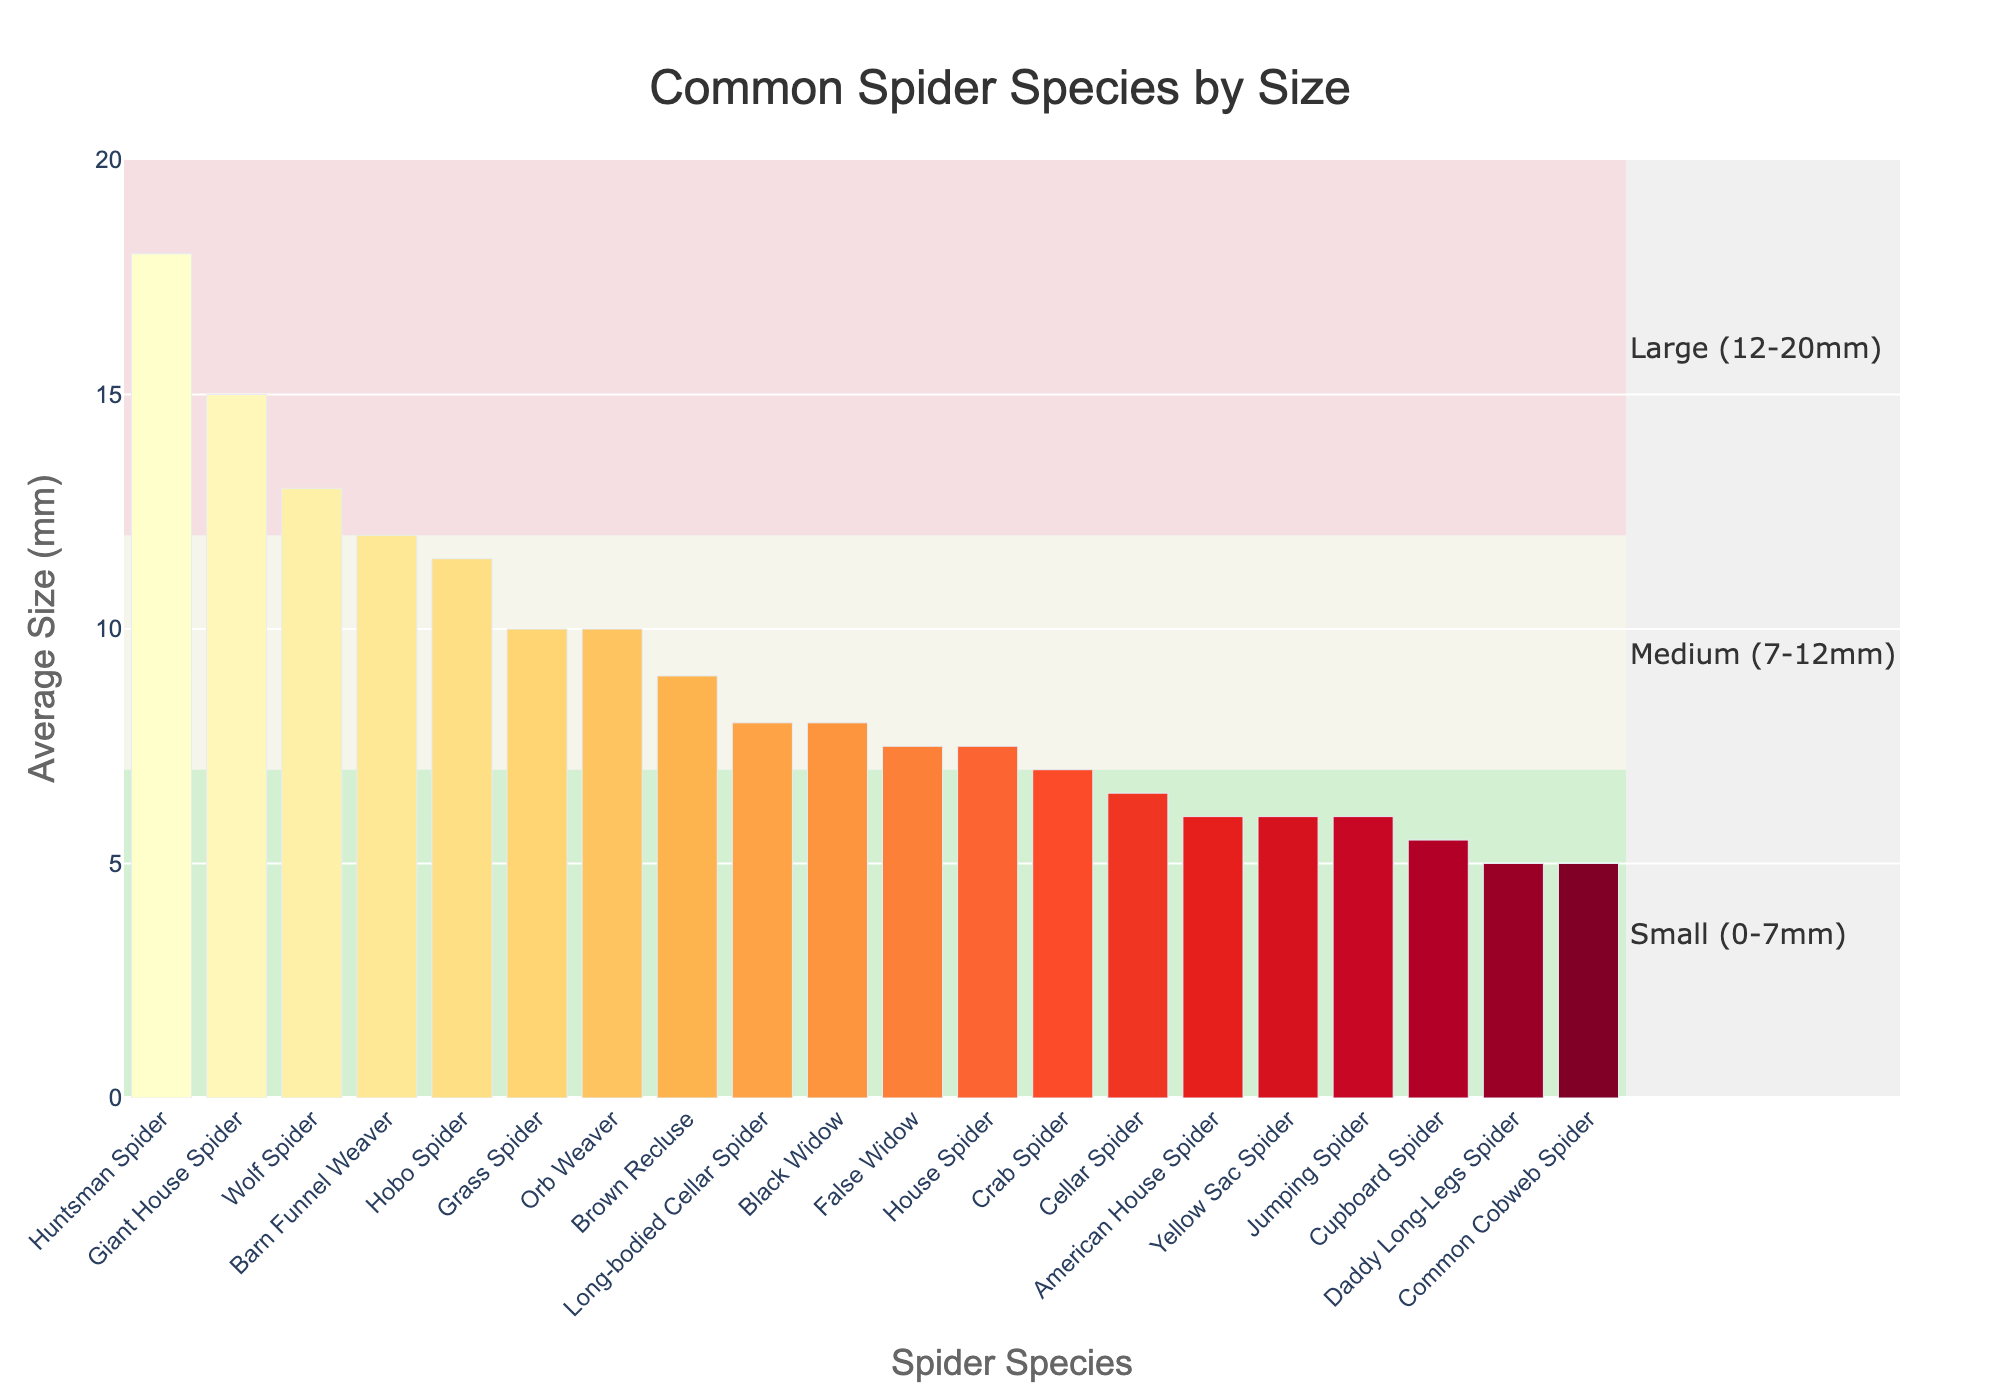Which spider species has the largest average size? The largest bar in the chart is for the Huntsman Spider, which has an average size of 18 mm.
Answer: Huntsman Spider Which spider species falls into the "Large (12-20mm)" size category? The spiders in the "Large (12-20mm)" category are those with average sizes between 12 mm and 20 mm. From the chart, these species are Wolf Spider (13 mm), Giant House Spider (15 mm), Barn Funnel Weaver (12 mm), and Huntsman Spider (18 mm).
Answer: Wolf Spider, Giant House Spider, Barn Funnel Weaver, Huntsman Spider Compare the average sizes of the Hobo Spider and the Orb Weaver. Which one is bigger? By looking at the heights of the bars for Hobo Spider and Orb Weaver, the Hobo Spider has an average size of 11.5 mm, whereas the Orb Weaver has an average size of 10 mm. Hence, Hobo Spider is bigger.
Answer: Hobo Spider What is the average size difference between the Cellar Spider and the Daddy Long-Legs Spider? The height of the Cellar Spider bar indicates it is 6.5 mm, and the Daddy Long-Legs Spider bar shows 5 mm. Subtract the size of Daddy Long-Legs Spider from the size of the Cellar Spider (6.5 mm - 5 mm).
Answer: 1.5 mm Which spider species has an equal average size to House Spider? The chart shows that the bar heights for House Spider and False Widow are both 7.5 mm.
Answer: False Widow How many spider species have an average size greater than 10 mm? Inspecting the bars taller than 10 mm, we find these species: Hobo Spider (11.5 mm), Giant House Spider (15 mm), Wolf Spider (13 mm), Barn Funnel Weaver (12 mm), and Huntsman Spider (18 mm). Counting these gives a total of 5 species.
Answer: 5 What is the combined average size of the Grass Spider and the Common Cobweb Spider? The Grass Spider has an average size of 10 mm and the Common Cobweb Spider has an average size of 5 mm. Summing these sizes (10 mm + 5 mm) gives the total.
Answer: 15 mm If you add the average sizes of the Crab Spider, American House Spider, and Cupboard Spider, what is the total? The Crab Spider is 7 mm, American House Spider is 6 mm, and Cupboard Spider is 5.5 mm. Adding these sizes (7 mm + 6 mm + 5.5 mm) gives the total.
Answer: 18.5 mm Which spider species has a size that falls in the middle of the "Medium (7-12mm)" category by average size? The spiders in the "Medium (7-12mm)" category are those between 7 mm and 12 mm. From the chart, this includes House Spider (7.5 mm), Jumping Spider (6 mm), Cellar Spider (6.5 mm), Yellow Sac Spider (6 mm), Orb Weaver (10 mm), Hobo Spider (11.5 mm), Crab Spider (7 mm), False Widow (7.5 mm), Long-bodied Cellar Spider (8 mm). Listing these in order and finding the middle value (when arranged in ascending order) gives the Long-bodied Cellar Spider at 8 mm.
Answer: Long-bodied Cellar Spider 